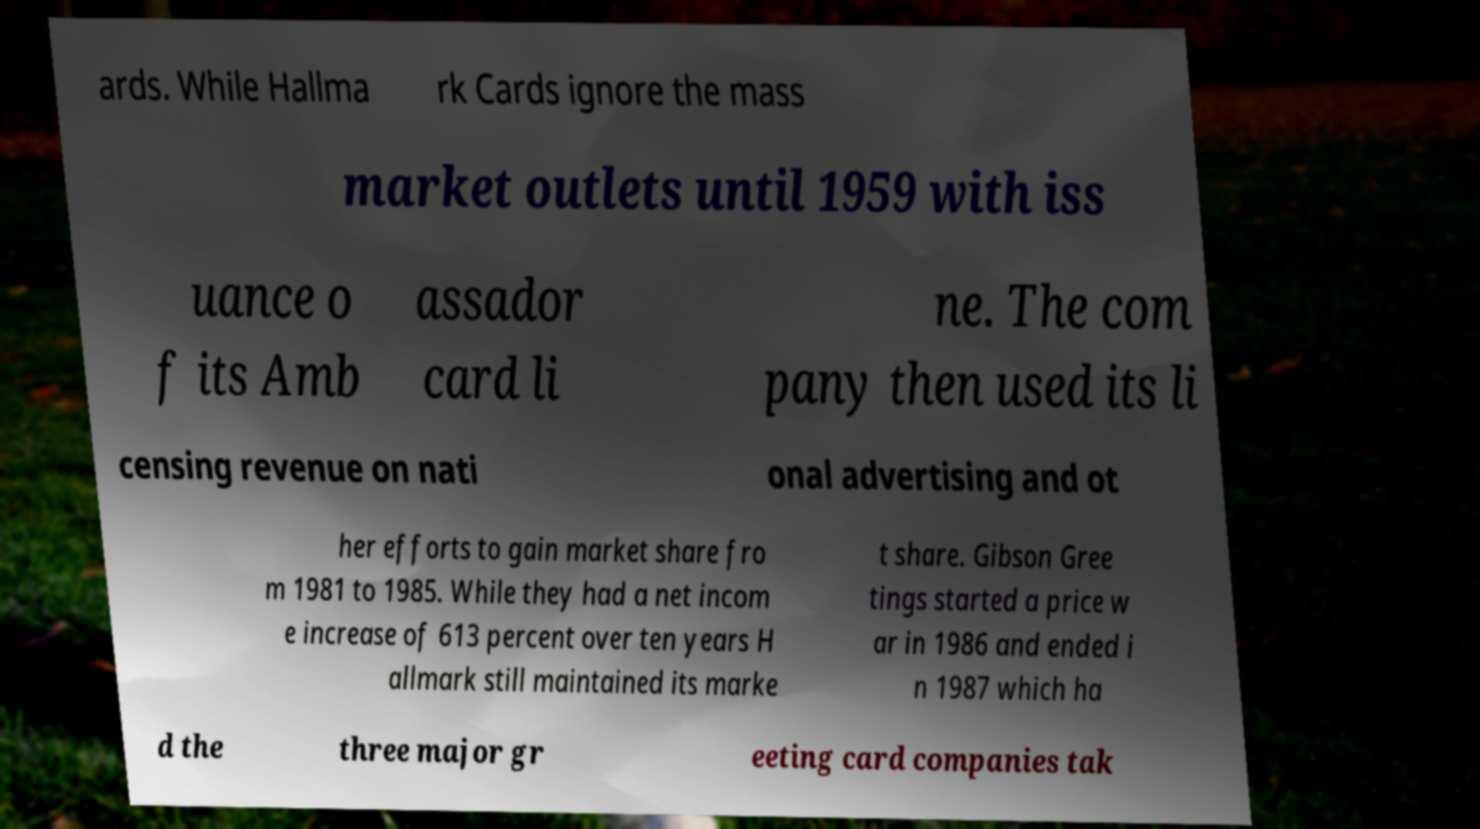What messages or text are displayed in this image? I need them in a readable, typed format. ards. While Hallma rk Cards ignore the mass market outlets until 1959 with iss uance o f its Amb assador card li ne. The com pany then used its li censing revenue on nati onal advertising and ot her efforts to gain market share fro m 1981 to 1985. While they had a net incom e increase of 613 percent over ten years H allmark still maintained its marke t share. Gibson Gree tings started a price w ar in 1986 and ended i n 1987 which ha d the three major gr eeting card companies tak 